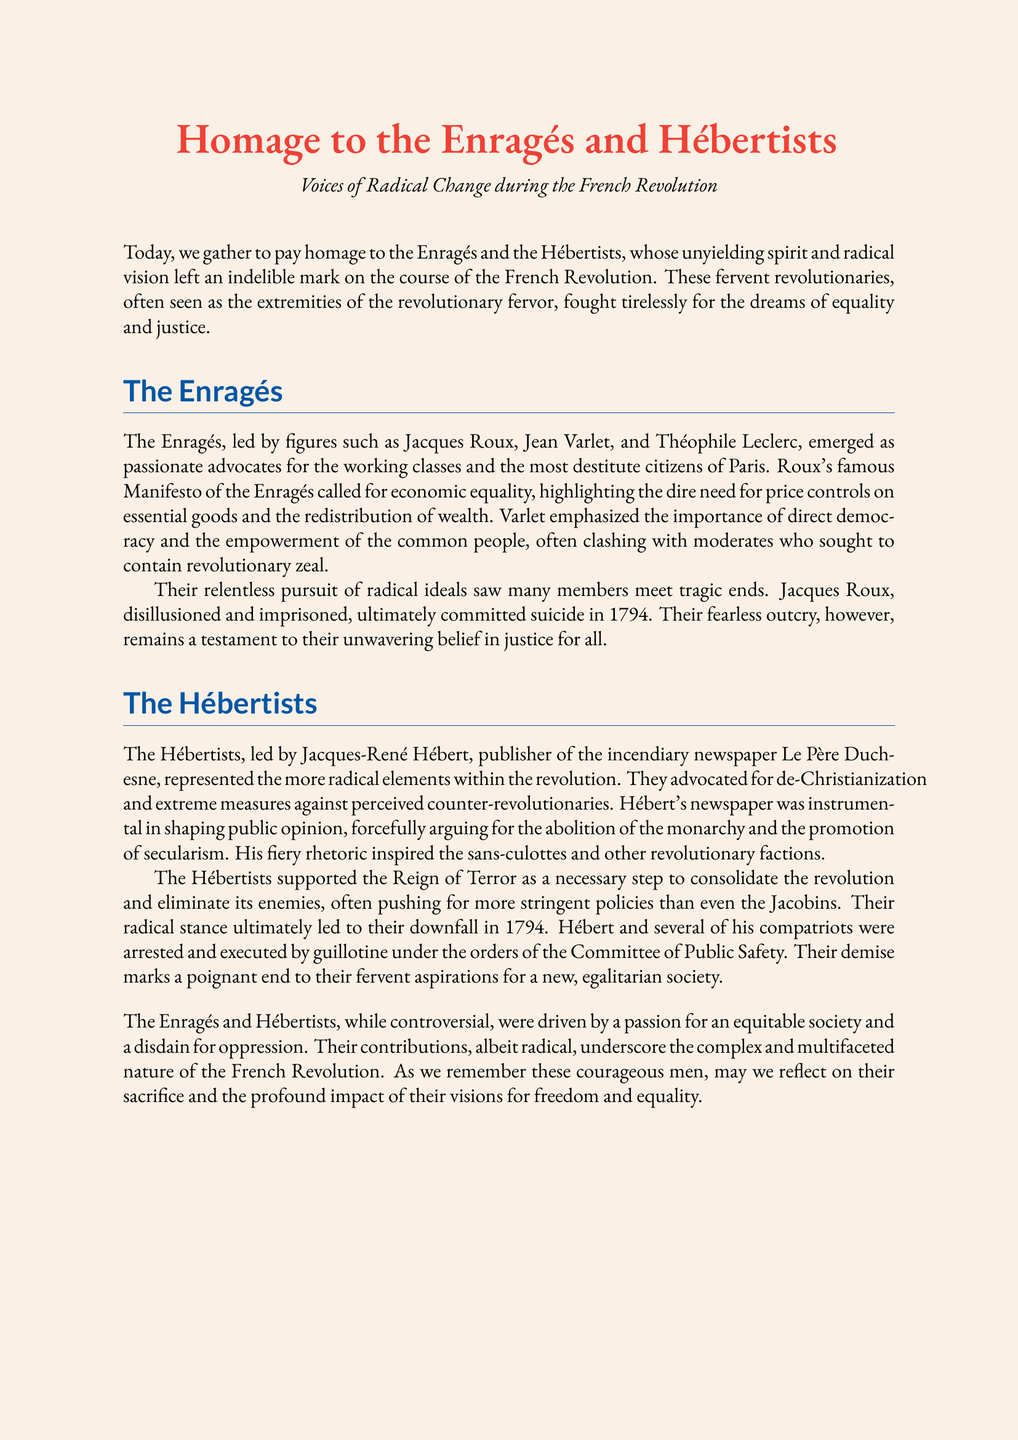What was the main belief of the Enragés? The Enragés believed in economic equality, advocating for price controls and wealth redistribution.
Answer: Economic equality Who was the leader of the Hébertists? Jacques-René Hébert was the prominent leader of the Hébertists.
Answer: Jacques-René Hébert What was the title of the Enragés' famous manifesto? The Enragés' main document was titled the Manifesto of the Enragés.
Answer: Manifesto of the Enragés In what year did Jacques Roux commit suicide? Jacques Roux committed suicide in the year 1794.
Answer: 1794 What was the name of Hébert's newspaper? The newspaper published by Hébert was called Le Père Duchesne.
Answer: Le Père Duchesne What ultimate fate did the Hébertists meet in 1794? The Hébertists were arrested and executed by guillotine in 1794.
Answer: Guillotine What was the primary call of Jacques Roux? Jacques Roux called for economic equality and price controls.
Answer: Economic equality and price controls How did the Enragés view the Revolution? The Enragés viewed the Revolution as a platform for justice for all.
Answer: Justice for all What was the Enragés' view on direct democracy? The Enragés emphasized the importance of direct democracy and common people's empowerment.
Answer: Direct democracy 